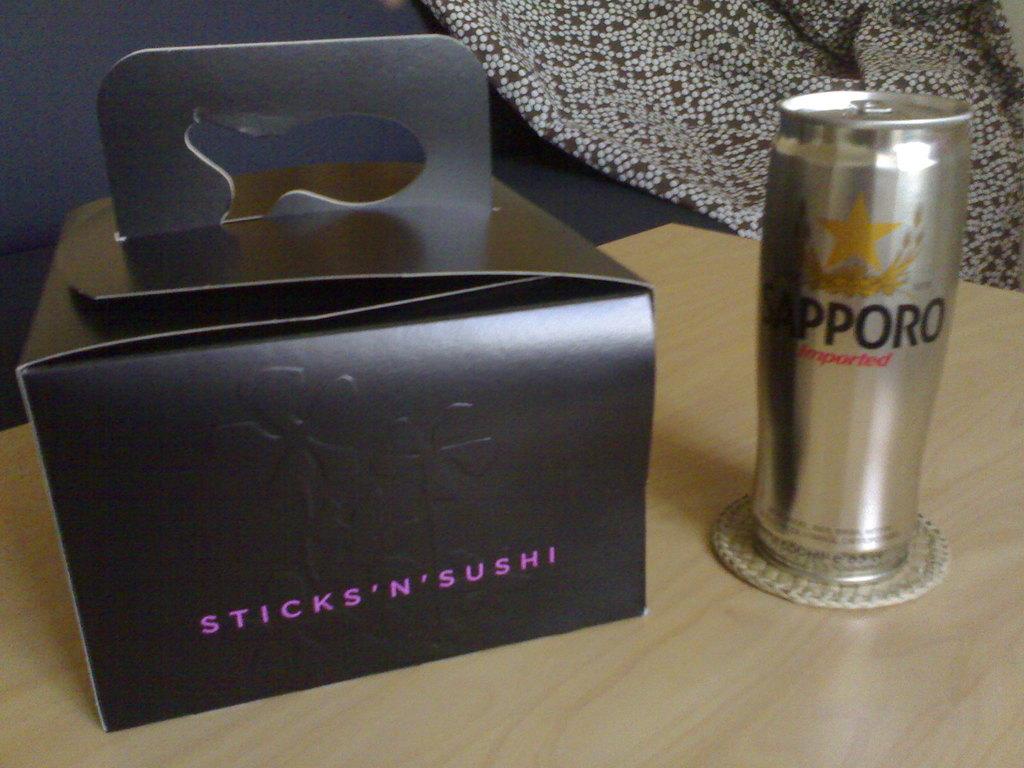What brand of beverage is in the can?
Provide a short and direct response. Sapporo. What is the brand of the box on the left?
Give a very brief answer. Sticks 'n' sushi. 